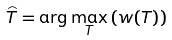Convert formula to latex. <formula><loc_0><loc_0><loc_500><loc_500>\widehat { T } = \arg \max _ { T } \left ( w ( T ) \right )</formula> 